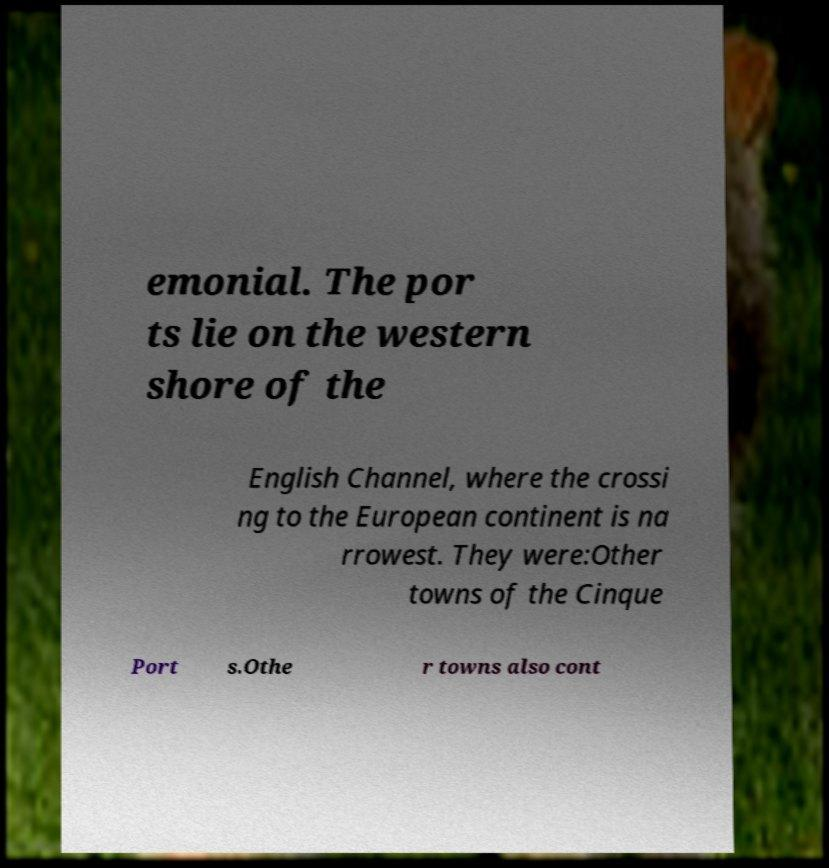There's text embedded in this image that I need extracted. Can you transcribe it verbatim? emonial. The por ts lie on the western shore of the English Channel, where the crossi ng to the European continent is na rrowest. They were:Other towns of the Cinque Port s.Othe r towns also cont 